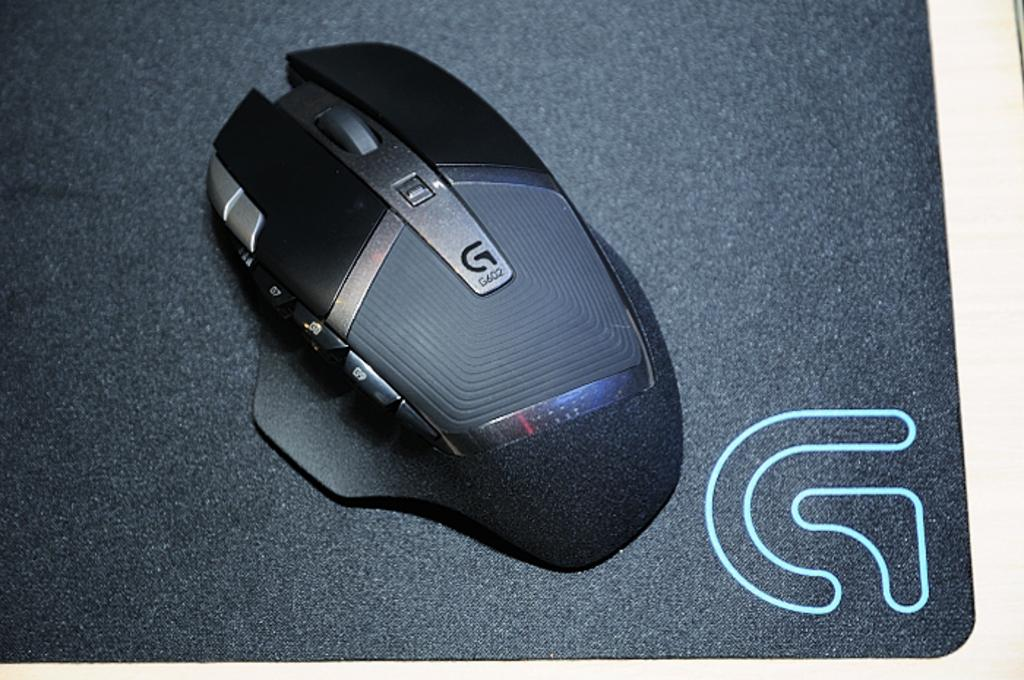What type of computer accessory is in the image? There is a wireless mouse in the image. Where is the wireless mouse located? The wireless mouse is on an object. Can you describe any additional features of the image? There is a watermark in the bottom right side of the image. What attempt was made to escape from jail in the image? There is no mention of a jail or an escape attempt in the image. 